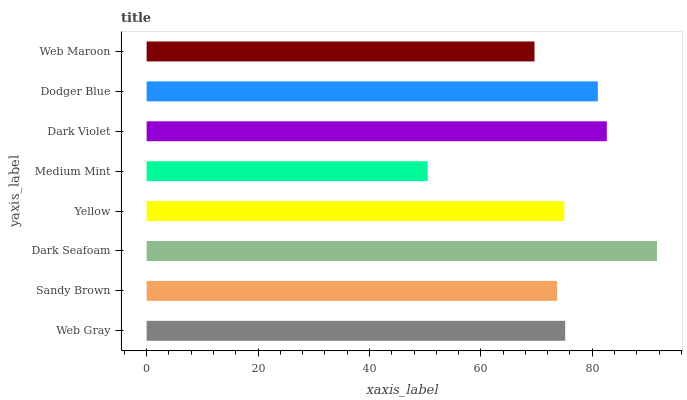Is Medium Mint the minimum?
Answer yes or no. Yes. Is Dark Seafoam the maximum?
Answer yes or no. Yes. Is Sandy Brown the minimum?
Answer yes or no. No. Is Sandy Brown the maximum?
Answer yes or no. No. Is Web Gray greater than Sandy Brown?
Answer yes or no. Yes. Is Sandy Brown less than Web Gray?
Answer yes or no. Yes. Is Sandy Brown greater than Web Gray?
Answer yes or no. No. Is Web Gray less than Sandy Brown?
Answer yes or no. No. Is Web Gray the high median?
Answer yes or no. Yes. Is Yellow the low median?
Answer yes or no. Yes. Is Web Maroon the high median?
Answer yes or no. No. Is Dark Violet the low median?
Answer yes or no. No. 